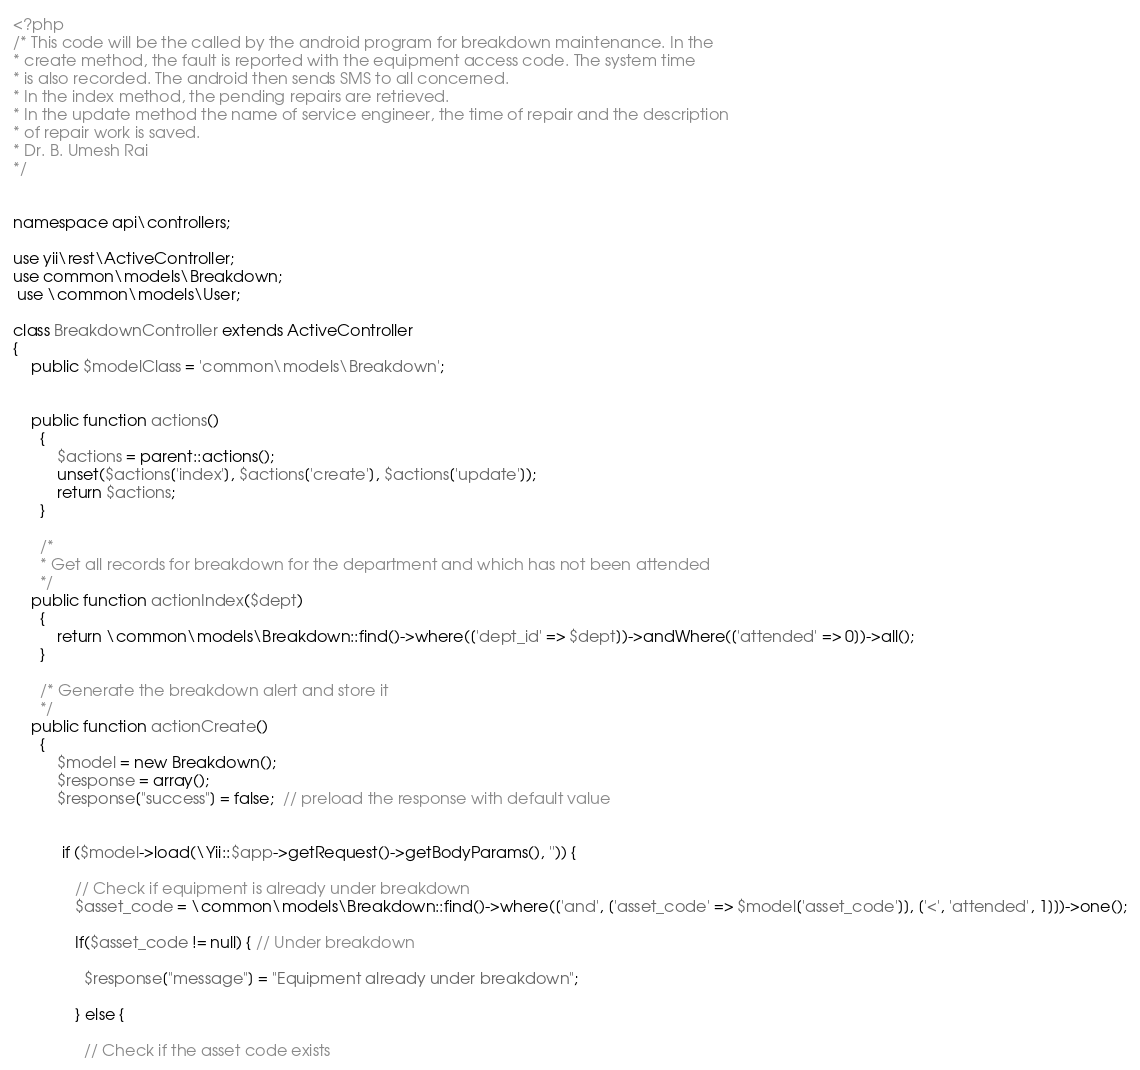Convert code to text. <code><loc_0><loc_0><loc_500><loc_500><_PHP_><?php
/* This code will be the called by the android program for breakdown maintenance. In the
* create method, the fault is reported with the equipment access code. The system time
* is also recorded. The android then sends SMS to all concerned.
* In the index method, the pending repairs are retrieved.
* In the update method the name of service engineer, the time of repair and the description
* of repair work is saved.
* Dr. B. Umesh Rai
*/


namespace api\controllers;

use yii\rest\ActiveController;
use common\models\Breakdown;
 use \common\models\User;

class BreakdownController extends ActiveController
{
    public $modelClass = 'common\models\Breakdown';

    
    public function actions()
      {
          $actions = parent::actions();
          unset($actions['index'], $actions['create'], $actions['update']);
          return $actions;
      }

      /*
      * Get all records for breakdown for the department and which has not been attended
      */
    public function actionIndex($dept)
      {
          return \common\models\Breakdown::find()->where(['dept_id' => $dept])->andWhere(['attended' => 0])->all(); 
      }

      /* Generate the breakdown alert and store it
      */
    public function actionCreate()
      {
          $model = new Breakdown(); 
          $response = array();
          $response["success"] = false;  // preload the response with default value
          

           if ($model->load(\Yii::$app->getRequest()->getBodyParams(), '')) {

              // Check if equipment is already under breakdown
              $asset_code = \common\models\Breakdown::find()->where(['and', ['asset_code' => $model['asset_code']], ['<', 'attended', 1]])->one();
              
              If($asset_code != null) { // Under breakdown
                
                $response["message"] = "Equipment already under breakdown";
              
              } else {

                // Check if the asset code exists</code> 